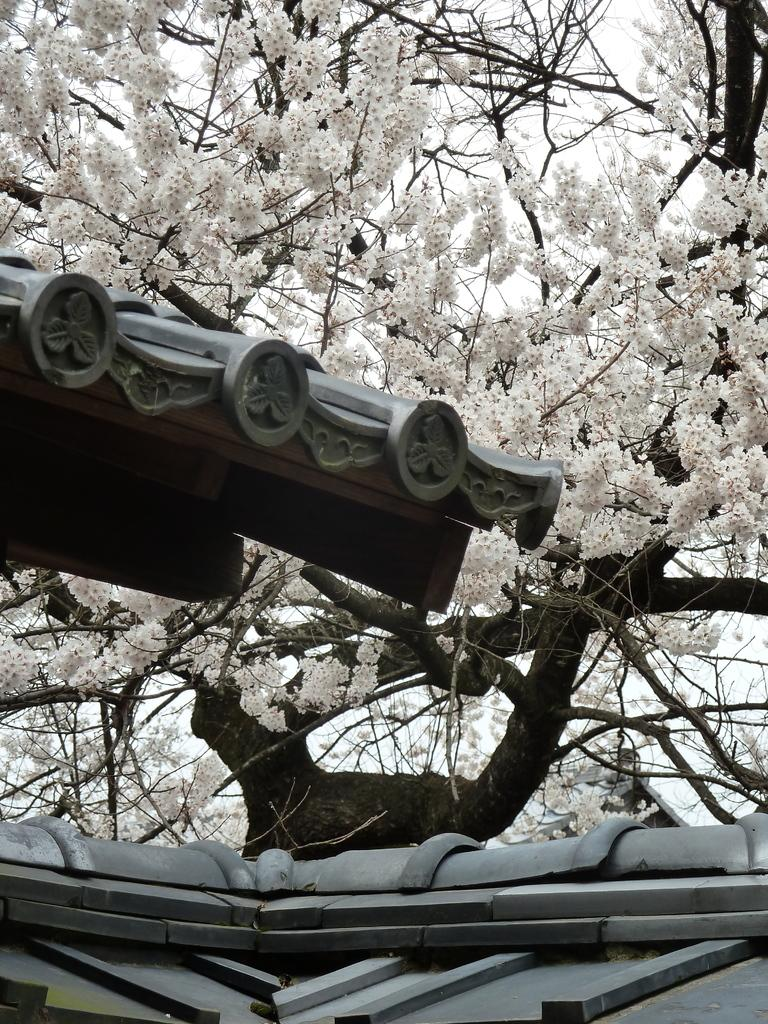What is present on top of the structure in the image? There is a roof in the picture. Can you describe the roof in the image? The roof has a design on it. What can be seen in the background of the image? There is a tree in the backdrop of the picture. What type of flowers are on the tree? The tree has white color flowers. How would you describe the sky in the image? The sky is clear in the image. Can you hear the guitar being played in the image? There is no guitar or sound present in the image, as it is a still picture. Is there a church visible in the image? There is no church present in the image. 